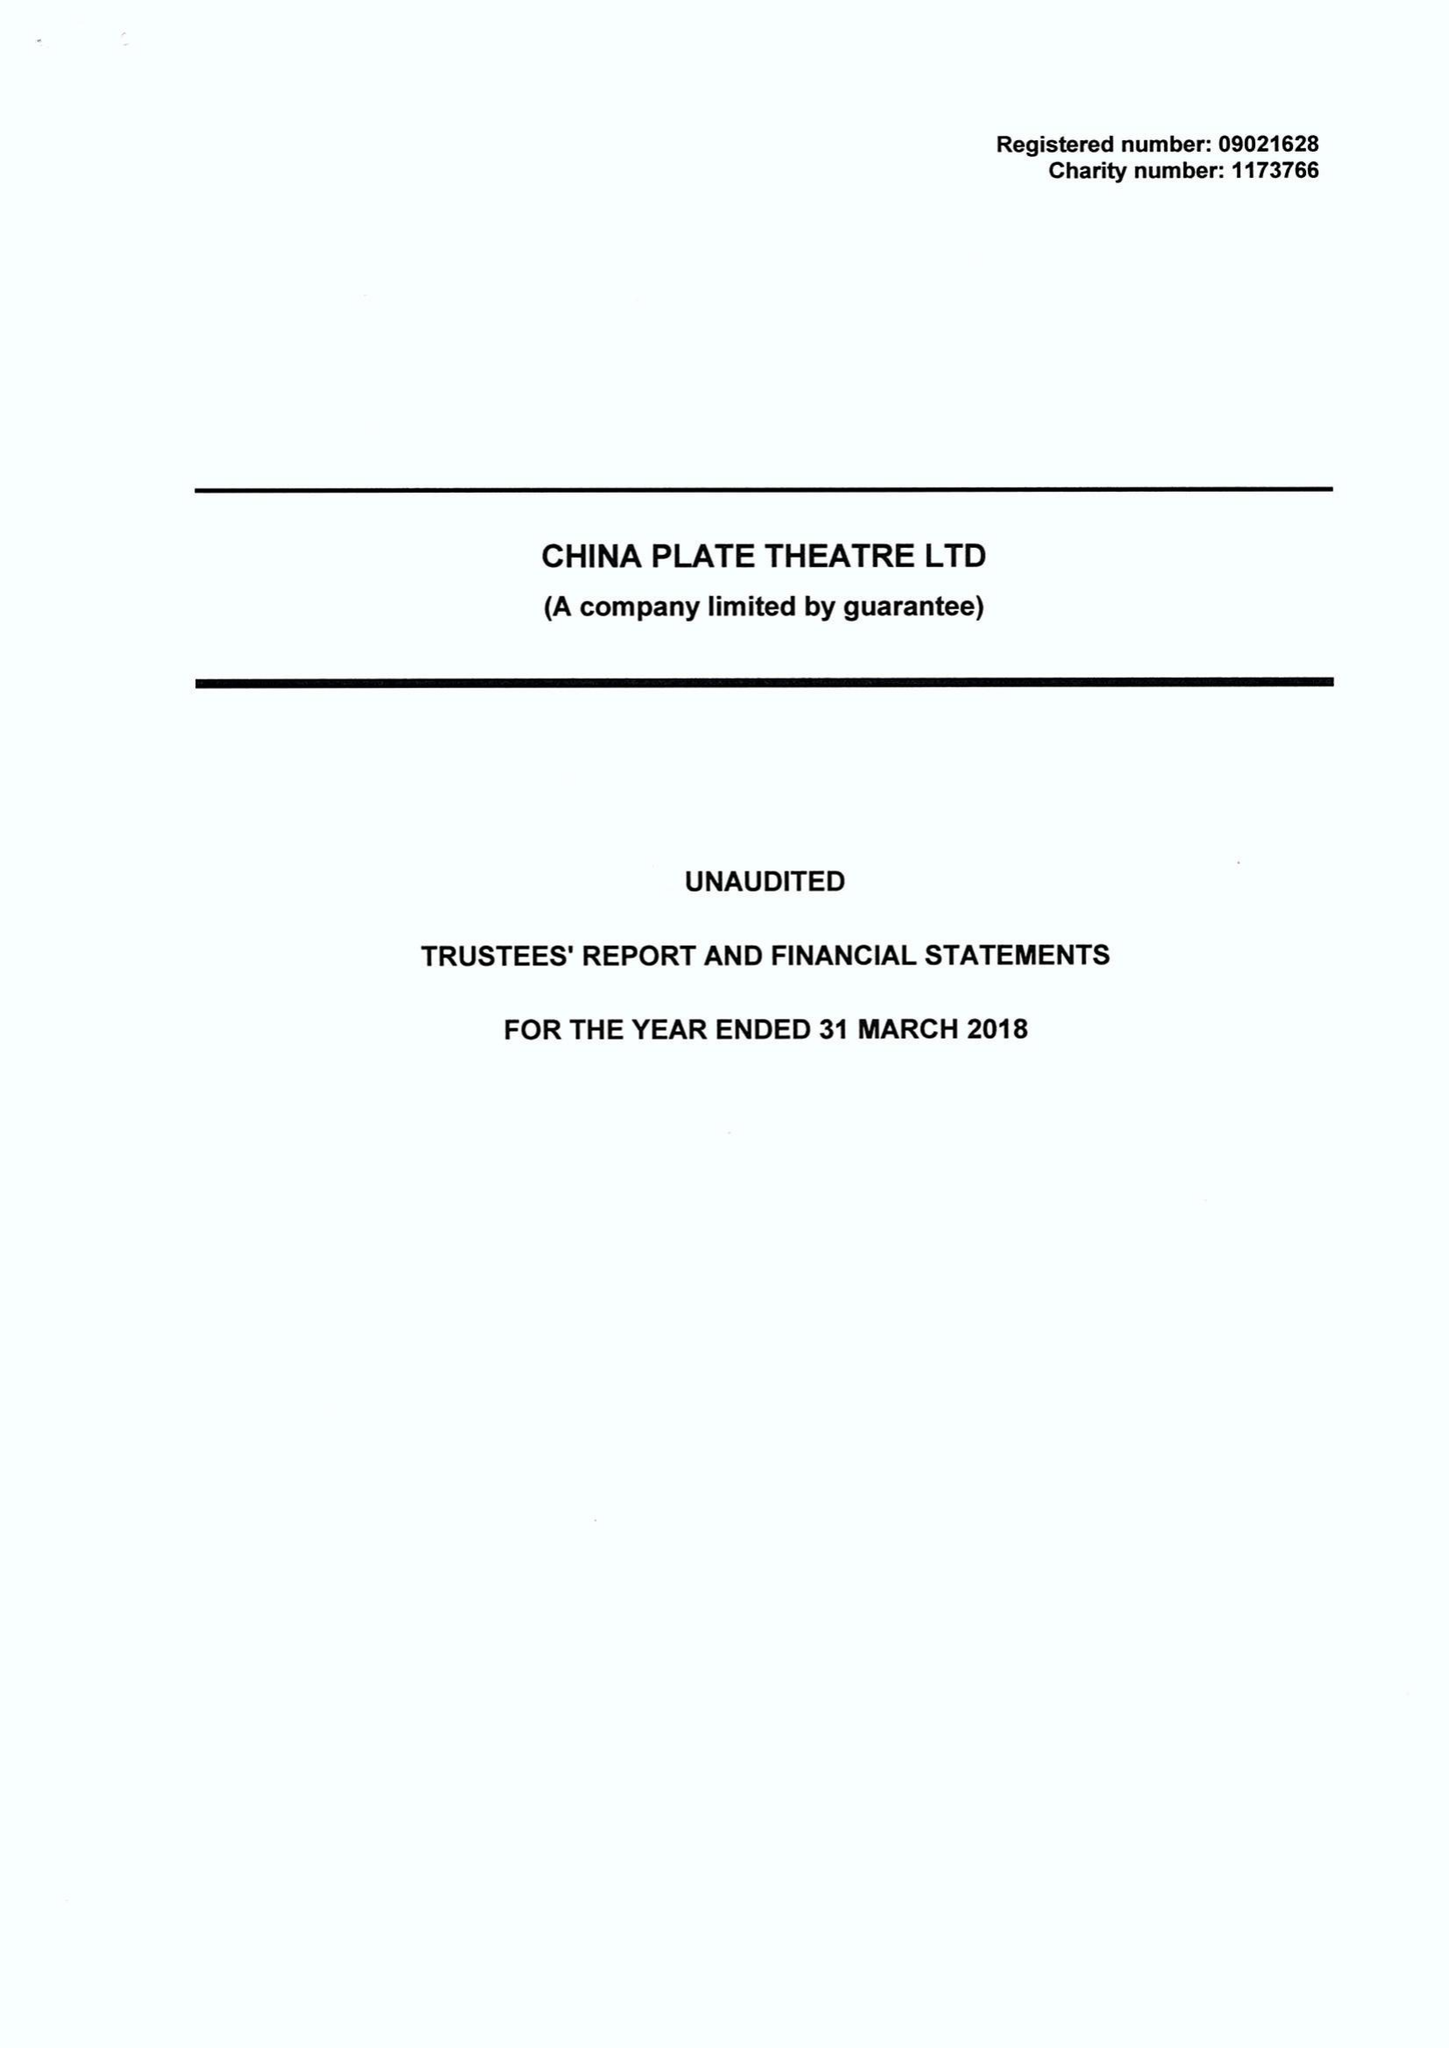What is the value for the spending_annually_in_british_pounds?
Answer the question using a single word or phrase. 473113.00 